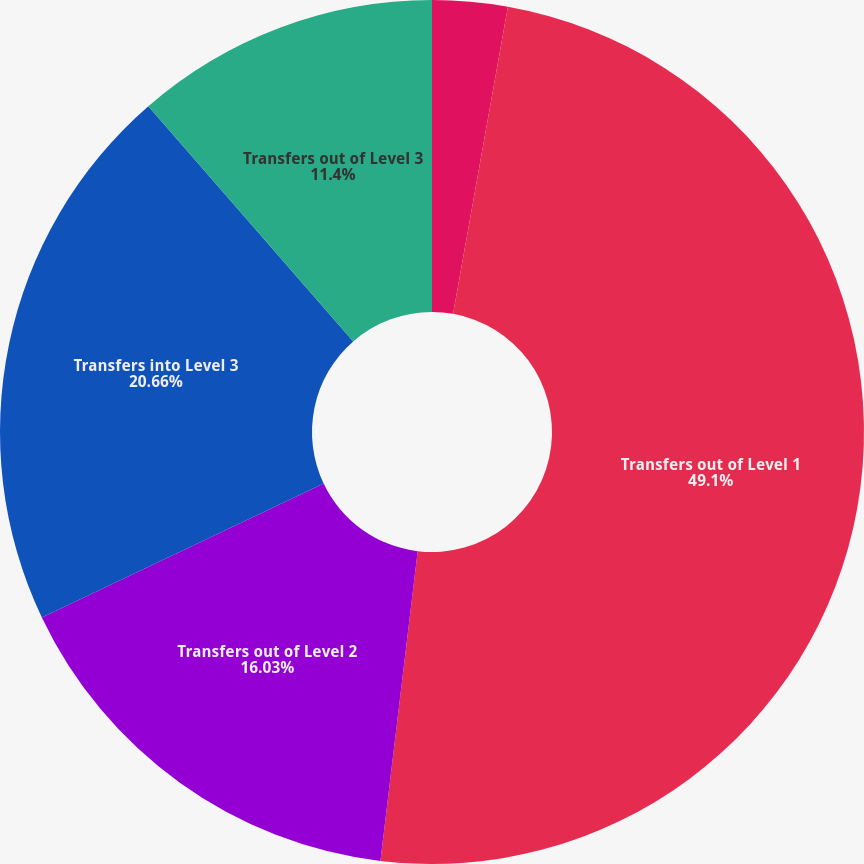<chart> <loc_0><loc_0><loc_500><loc_500><pie_chart><fcel>Transfers into Level 1<fcel>Transfers out of Level 1<fcel>Transfers out of Level 2<fcel>Transfers into Level 3<fcel>Transfers out of Level 3<nl><fcel>2.81%<fcel>49.09%<fcel>16.03%<fcel>20.66%<fcel>11.4%<nl></chart> 